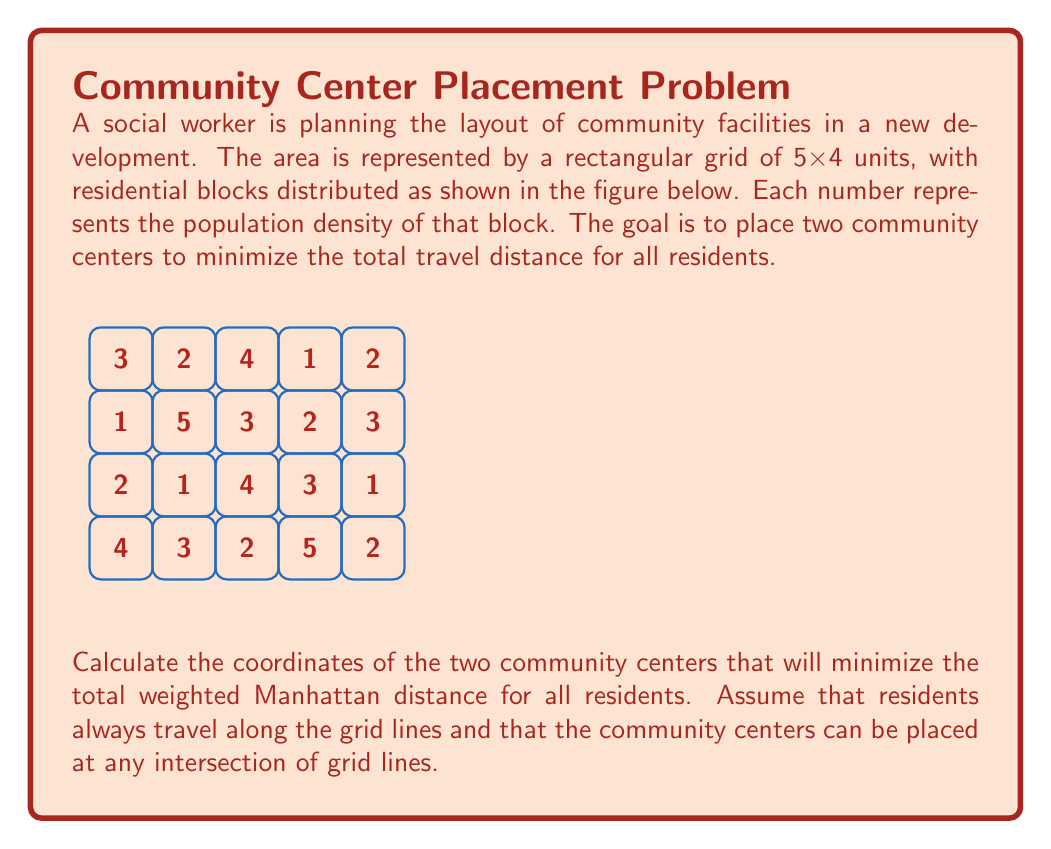Solve this math problem. To solve this problem, we'll use the concept of the geometric median, which minimizes the sum of distances to a set of points. In this case, we need to find two geometric medians that minimize the total weighted Manhattan distance.

Step 1: Calculate the total population and the weighted sum of x and y coordinates.
Total population: 3+2+4+1+2+1+5+3+2+3+2+1+4+3+1+4+3+2+5+2 = 53
Weighted sum of x: (0×3 + 1×2 + 2×4 + 3×1 + 4×2) + ... + (0×4 + 1×3 + 2×2 + 3×5 + 4×2) = 106
Weighted sum of y: (3×3 + 3×2 + 3×4 + 3×1 + 3×2) + ... + (0×4 + 0×3 + 0×2 + 0×5 + 0×2) = 79.5

Step 2: Calculate the center of mass.
Center of mass: (106/53, 79.5/53) ≈ (2, 1.5)

Step 3: Since we need two community centers, we'll split the area into two parts based on the center of mass. We'll use a vertical line at x=2 to divide the area.

Step 4: Calculate the geometric median for each half.
Left half (x ≤ 2):
Total population: 3+2+1+5+2+1+4+3 = 21
Weighted sum of x: 0×3 + 1×2 + 0×1 + 1×5 + 0×2 + 1×1 + 0×4 + 1×3 = 11
Weighted sum of y: 3×3 + 3×2 + 2×1 + 2×5 + 1×2 + 1×1 + 0×4 + 0×3 = 31
Geometric median for left half: (11/21, 31/21) ≈ (0.52, 1.48)

Right half (x > 2):
Total population: 4+1+2+3+2+3+4+3+1+2+5+2 = 32
Weighted sum of x: 2×4 + 3×1 + 4×2 + 2×3 + 3×2 + 4×3 + 2×4 + 3×3 + 4×1 + 2×2 + 3×5 + 4×2 = 95
Weighted sum of y: 3×4 + 3×1 + 3×2 + 2×3 + 2×2 + 2×3 + 1×4 + 1×3 + 1×1 + 0×2 + 0×5 + 0×2 = 48.5
Geometric median for right half: (95/32, 48.5/32) ≈ (2.97, 1.52)

Step 5: Round the coordinates to the nearest grid intersection.
Left community center: (1, 1)
Right community center: (3, 2)
Answer: (1, 1) and (3, 2) 